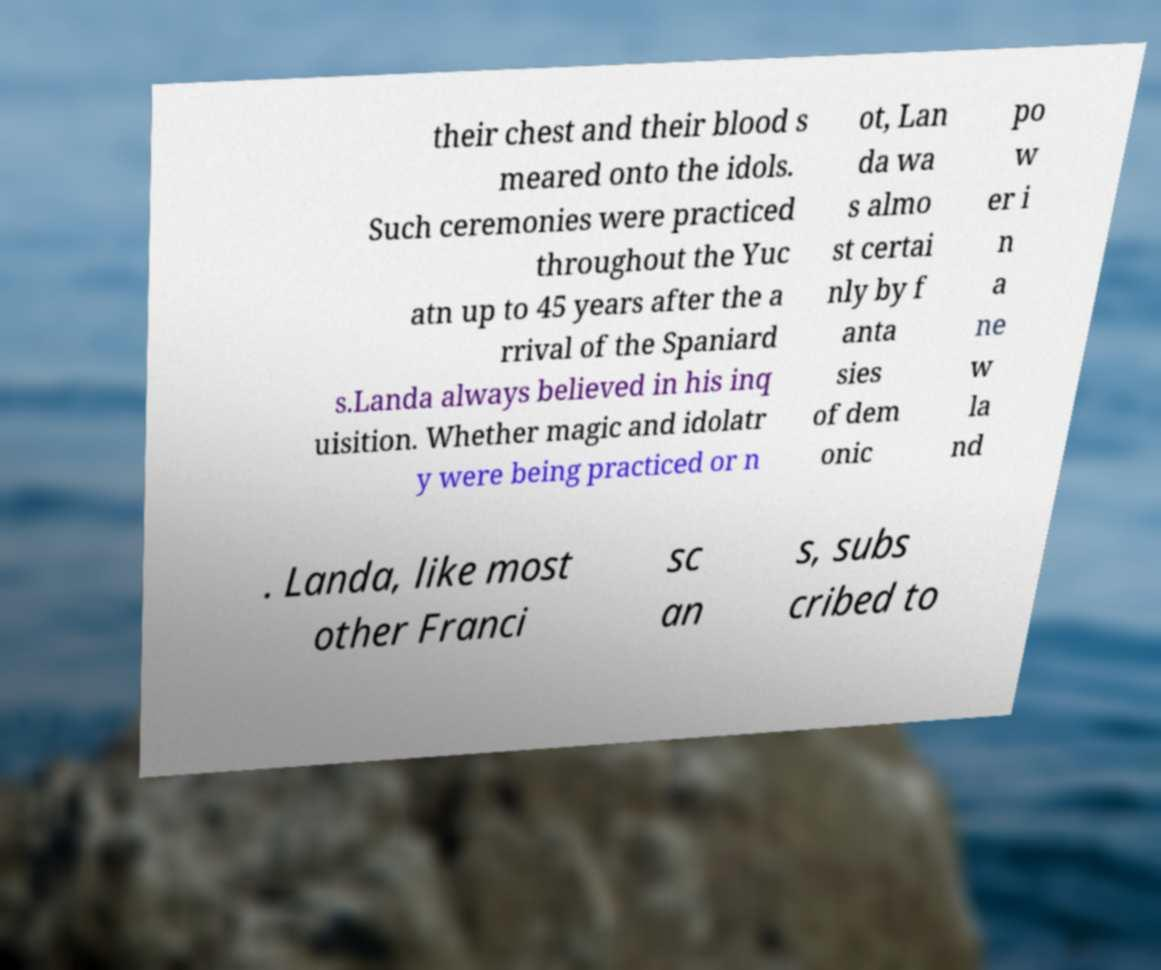Please identify and transcribe the text found in this image. their chest and their blood s meared onto the idols. Such ceremonies were practiced throughout the Yuc atn up to 45 years after the a rrival of the Spaniard s.Landa always believed in his inq uisition. Whether magic and idolatr y were being practiced or n ot, Lan da wa s almo st certai nly by f anta sies of dem onic po w er i n a ne w la nd . Landa, like most other Franci sc an s, subs cribed to 